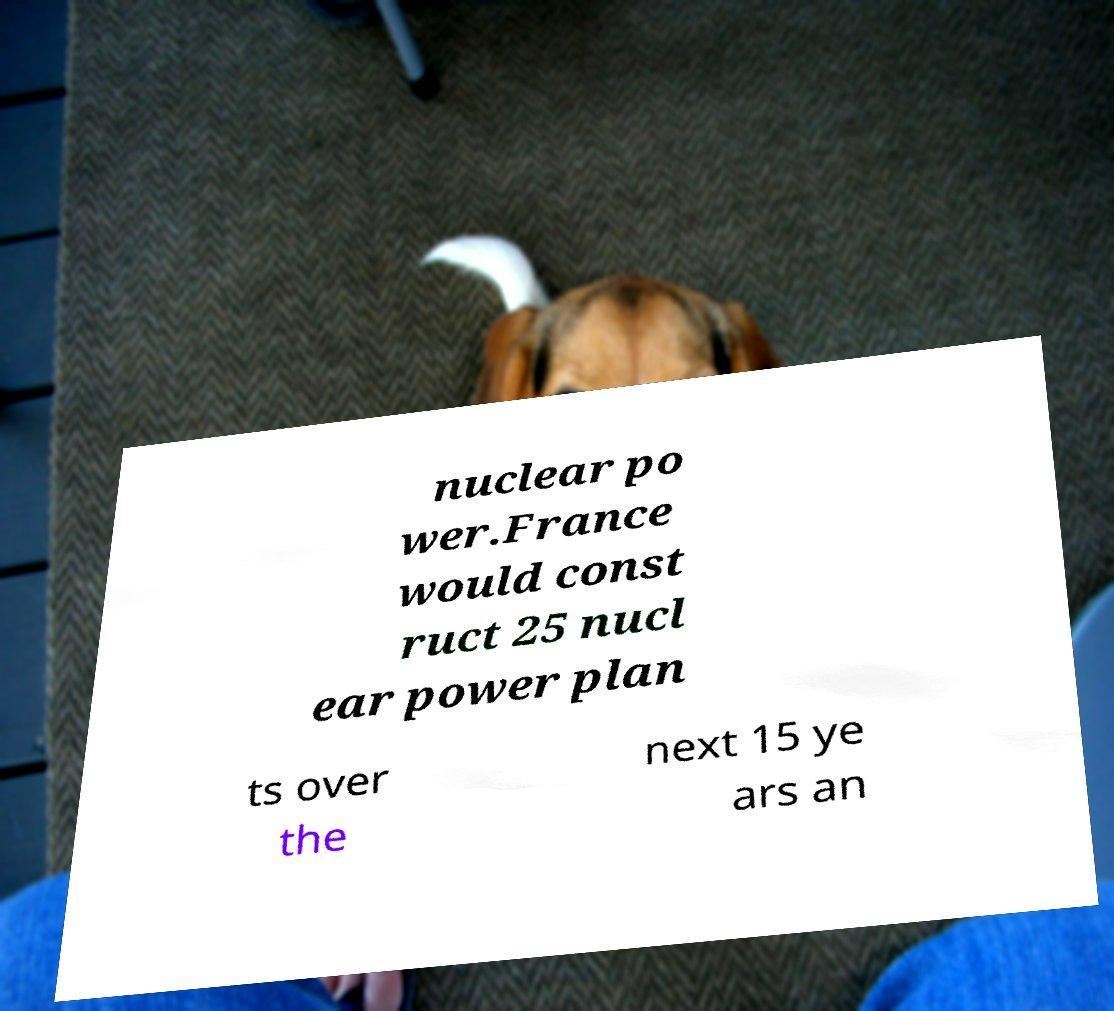I need the written content from this picture converted into text. Can you do that? nuclear po wer.France would const ruct 25 nucl ear power plan ts over the next 15 ye ars an 